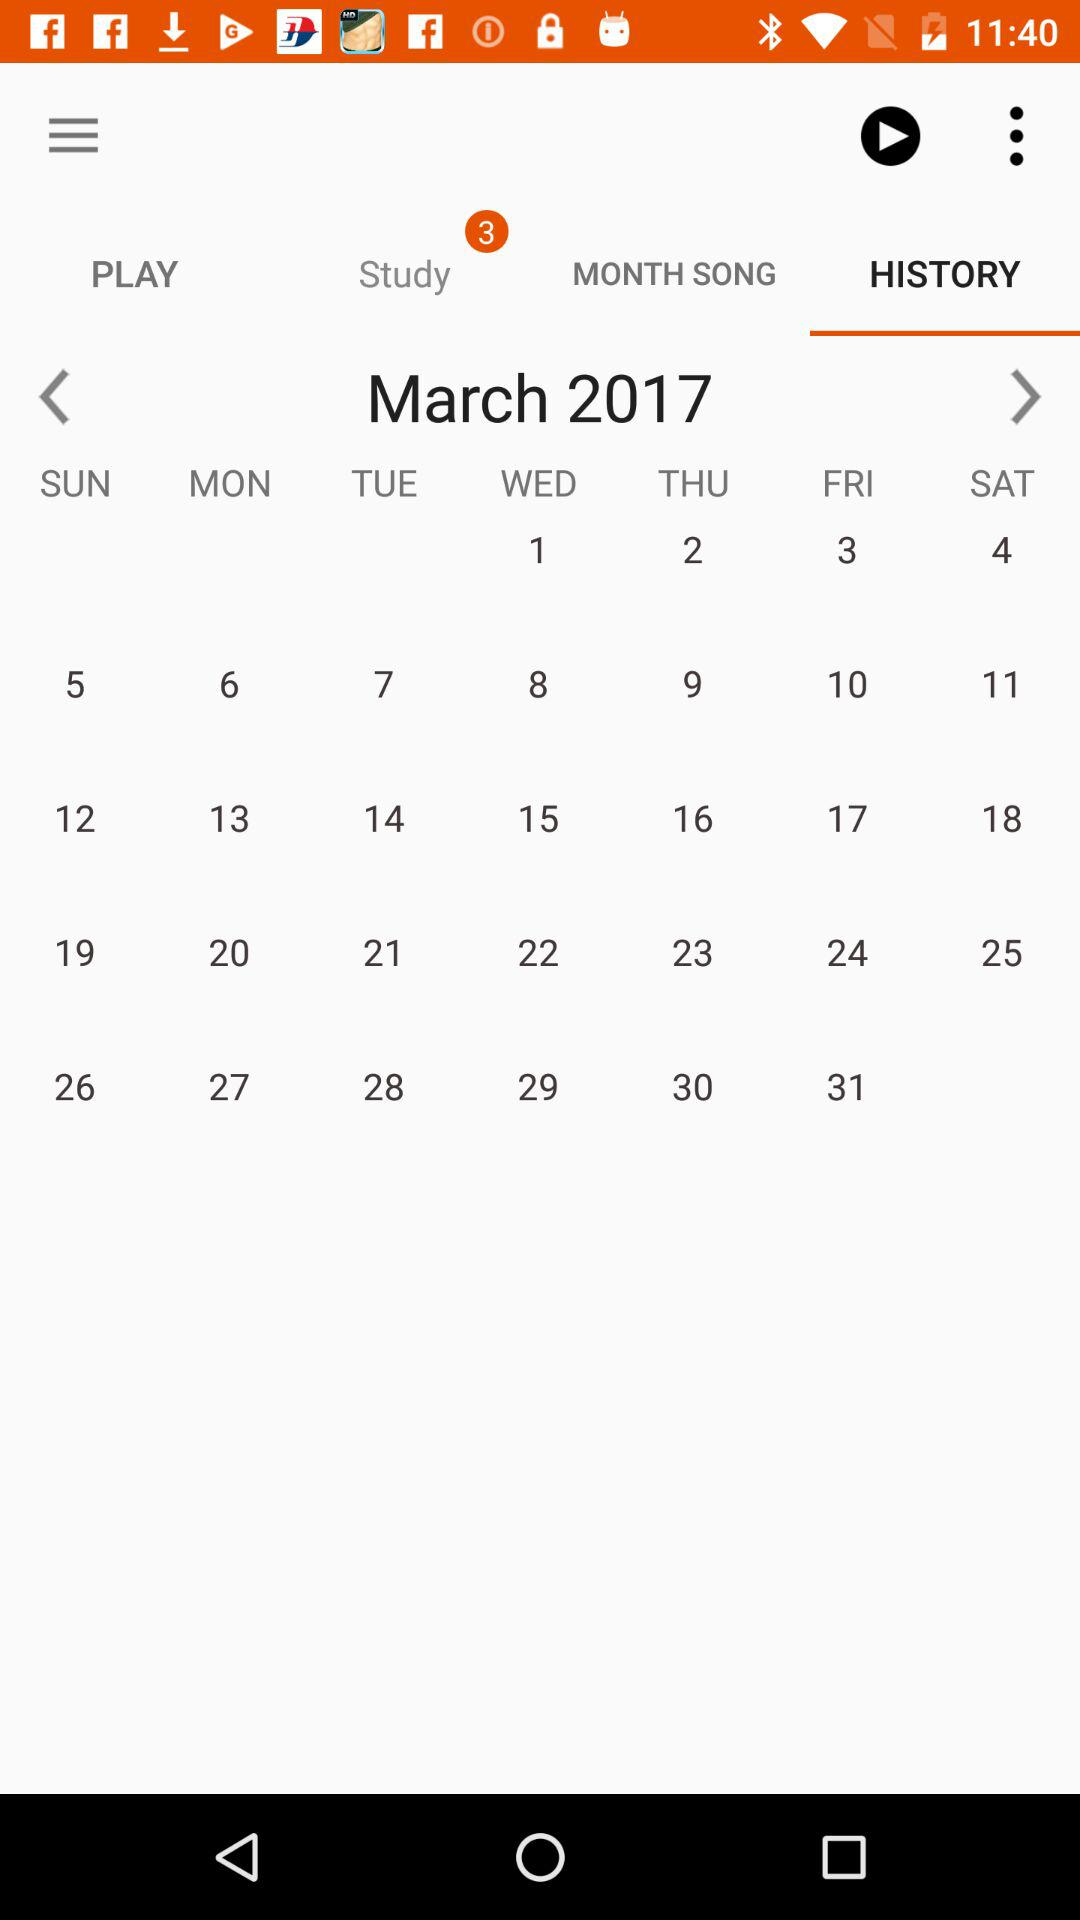Which month of the calendar is shown? The month that is shown on the calendar is March. 